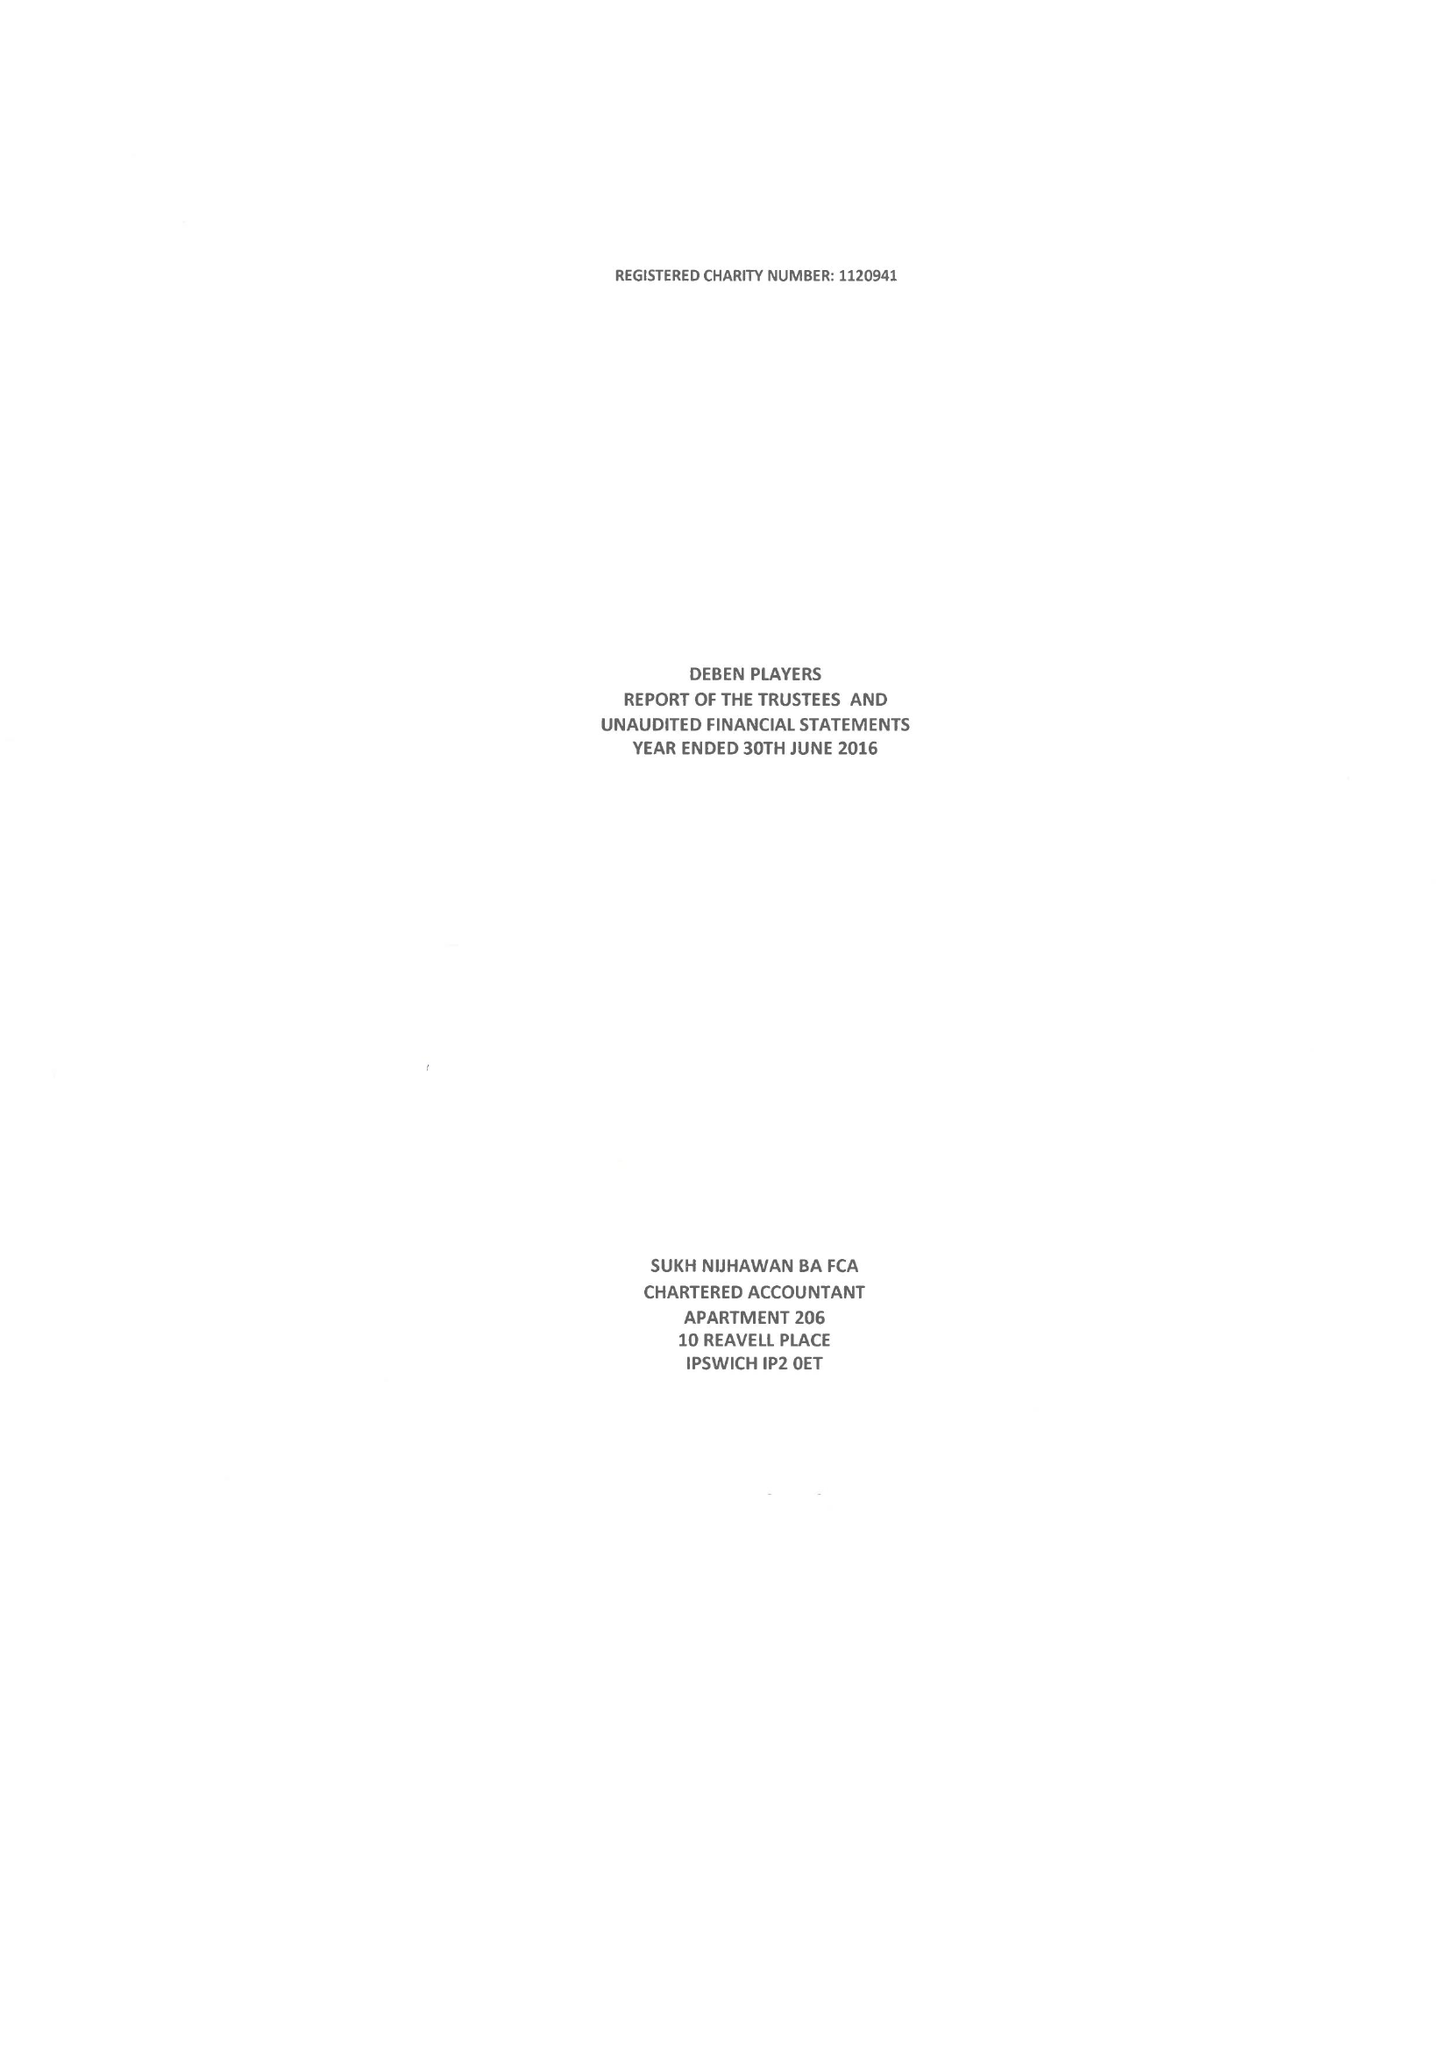What is the value for the address__street_line?
Answer the question using a single word or phrase. 1 NEWRY AVENUE 